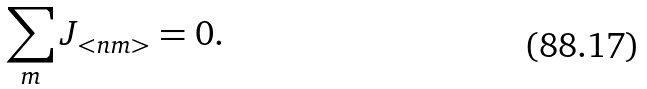Convert formula to latex. <formula><loc_0><loc_0><loc_500><loc_500>\sum _ { m } J _ { < n m > } = 0 .</formula> 